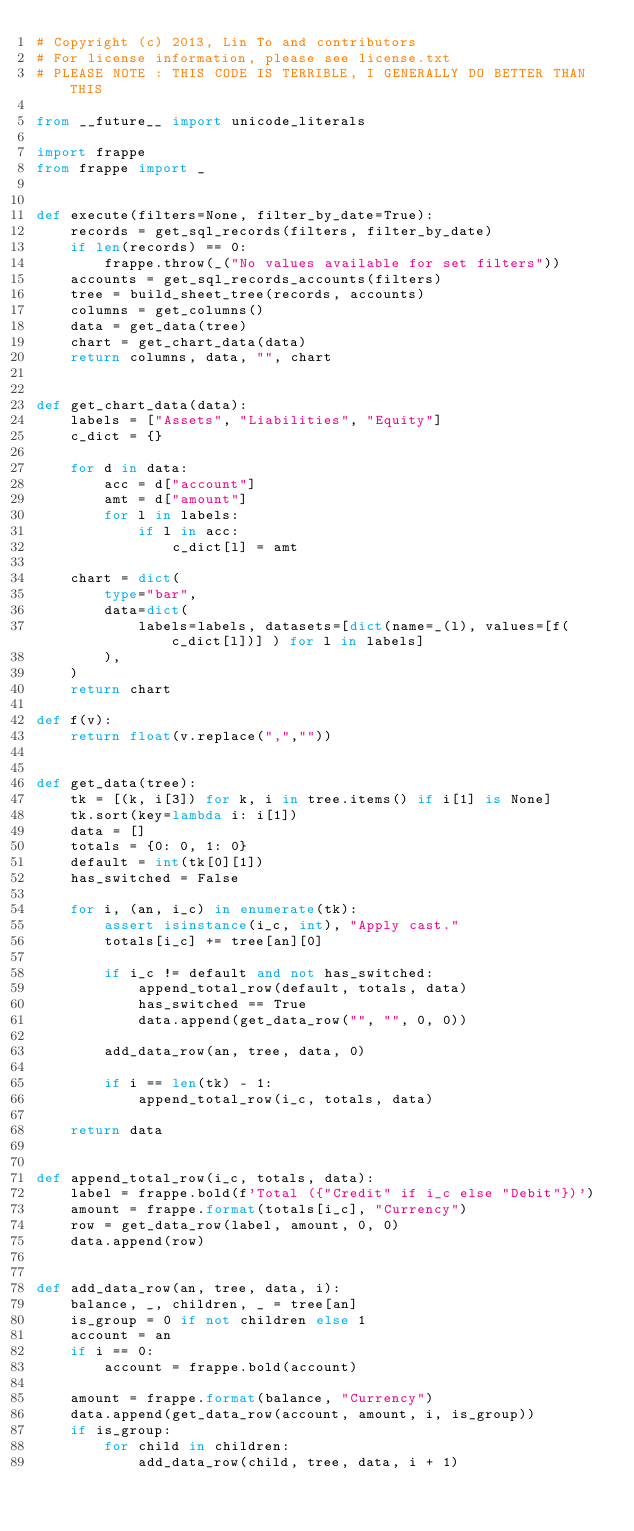Convert code to text. <code><loc_0><loc_0><loc_500><loc_500><_Python_># Copyright (c) 2013, Lin To and contributors
# For license information, please see license.txt
# PLEASE NOTE : THIS CODE IS TERRIBLE, I GENERALLY DO BETTER THAN THIS

from __future__ import unicode_literals

import frappe
from frappe import _


def execute(filters=None, filter_by_date=True):
    records = get_sql_records(filters, filter_by_date)
    if len(records) == 0:
        frappe.throw(_("No values available for set filters"))
    accounts = get_sql_records_accounts(filters)
    tree = build_sheet_tree(records, accounts)
    columns = get_columns()
    data = get_data(tree)
    chart = get_chart_data(data)
    return columns, data, "", chart


def get_chart_data(data):
    labels = ["Assets", "Liabilities", "Equity"]
    c_dict = {}

    for d in data:
        acc = d["account"]
        amt = d["amount"]
        for l in labels:
            if l in acc:
                c_dict[l] = amt

    chart = dict(
        type="bar",
        data=dict(
            labels=labels, datasets=[dict(name=_(l), values=[f(c_dict[l])] ) for l in labels]
        ),
    )
    return chart

def f(v):
    return float(v.replace(",",""))


def get_data(tree):
    tk = [(k, i[3]) for k, i in tree.items() if i[1] is None]
    tk.sort(key=lambda i: i[1])
    data = []
    totals = {0: 0, 1: 0}
    default = int(tk[0][1])
    has_switched = False

    for i, (an, i_c) in enumerate(tk):
        assert isinstance(i_c, int), "Apply cast."
        totals[i_c] += tree[an][0]

        if i_c != default and not has_switched:
            append_total_row(default, totals, data)
            has_switched == True
            data.append(get_data_row("", "", 0, 0))

        add_data_row(an, tree, data, 0)

        if i == len(tk) - 1:
            append_total_row(i_c, totals, data)

    return data


def append_total_row(i_c, totals, data):
    label = frappe.bold(f'Total ({"Credit" if i_c else "Debit"})')
    amount = frappe.format(totals[i_c], "Currency")
    row = get_data_row(label, amount, 0, 0)
    data.append(row)


def add_data_row(an, tree, data, i):
    balance, _, children, _ = tree[an]
    is_group = 0 if not children else 1
    account = an
    if i == 0:
        account = frappe.bold(account)

    amount = frappe.format(balance, "Currency")
    data.append(get_data_row(account, amount, i, is_group))
    if is_group:
        for child in children:
            add_data_row(child, tree, data, i + 1)

</code> 